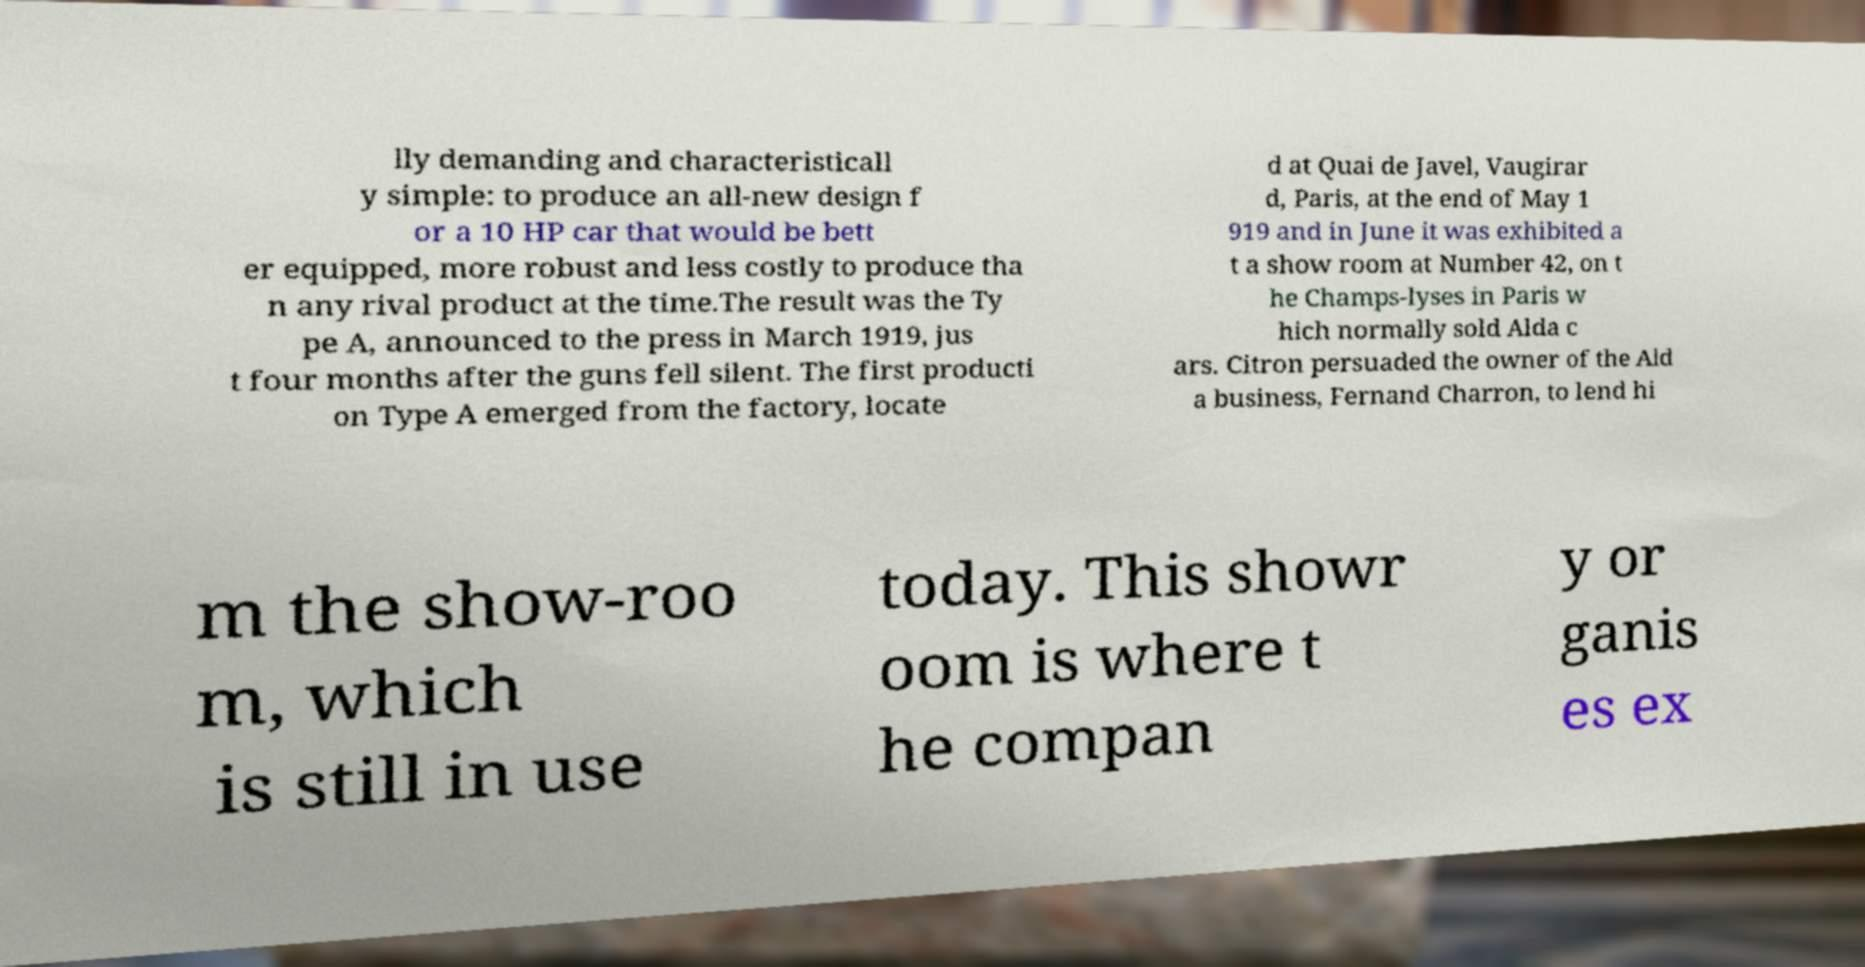Can you read and provide the text displayed in the image?This photo seems to have some interesting text. Can you extract and type it out for me? lly demanding and characteristicall y simple: to produce an all-new design f or a 10 HP car that would be bett er equipped, more robust and less costly to produce tha n any rival product at the time.The result was the Ty pe A, announced to the press in March 1919, jus t four months after the guns fell silent. The first producti on Type A emerged from the factory, locate d at Quai de Javel, Vaugirar d, Paris, at the end of May 1 919 and in June it was exhibited a t a show room at Number 42, on t he Champs-lyses in Paris w hich normally sold Alda c ars. Citron persuaded the owner of the Ald a business, Fernand Charron, to lend hi m the show-roo m, which is still in use today. This showr oom is where t he compan y or ganis es ex 